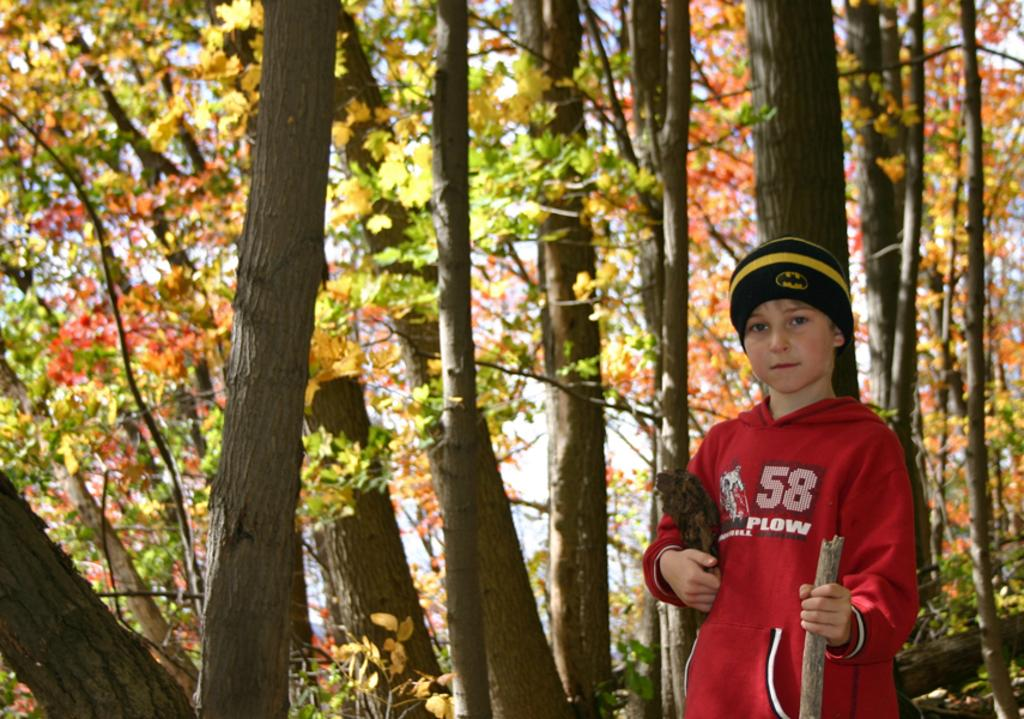<image>
Provide a brief description of the given image. A boy with 58 Plow on his shirt wears a black and yellow winter hat. 